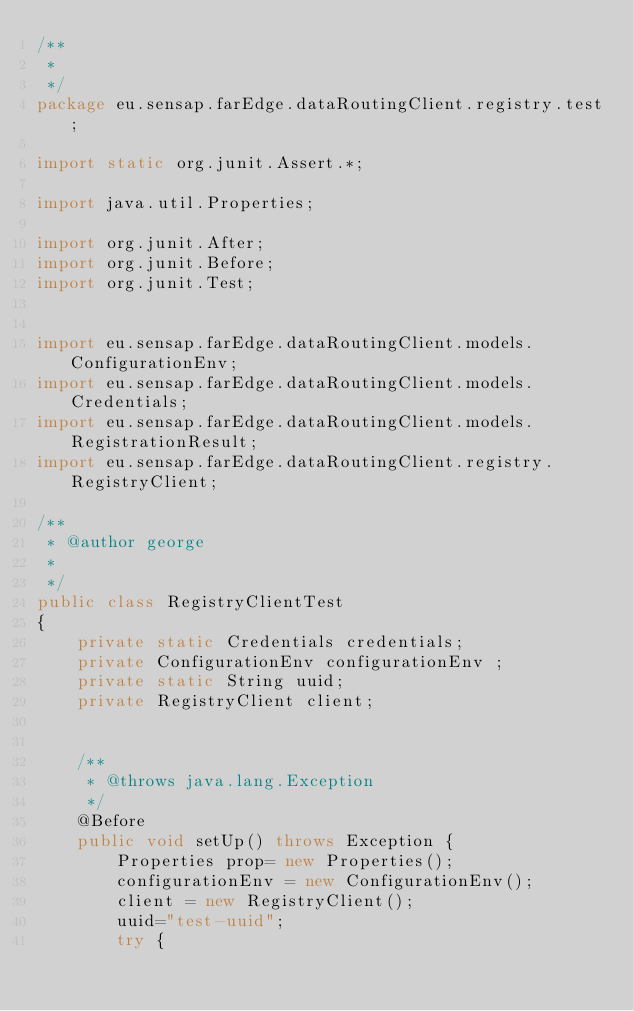Convert code to text. <code><loc_0><loc_0><loc_500><loc_500><_Java_>/**
 * 
 */
package eu.sensap.farEdge.dataRoutingClient.registry.test;

import static org.junit.Assert.*;

import java.util.Properties;

import org.junit.After;
import org.junit.Before;
import org.junit.Test;


import eu.sensap.farEdge.dataRoutingClient.models.ConfigurationEnv;
import eu.sensap.farEdge.dataRoutingClient.models.Credentials;
import eu.sensap.farEdge.dataRoutingClient.models.RegistrationResult;
import eu.sensap.farEdge.dataRoutingClient.registry.RegistryClient;

/**
 * @author george
 *
 */
public class RegistryClientTest
{
	private static Credentials credentials;		
	private ConfigurationEnv configurationEnv ;	
	private static String uuid;	
	private RegistryClient client;
	

	/**
	 * @throws java.lang.Exception
	 */
	@Before
	public void setUp() throws Exception {
		Properties prop= new Properties();
		configurationEnv = new ConfigurationEnv();
		client = new RegistryClient();
		uuid="test-uuid";
		try {</code> 